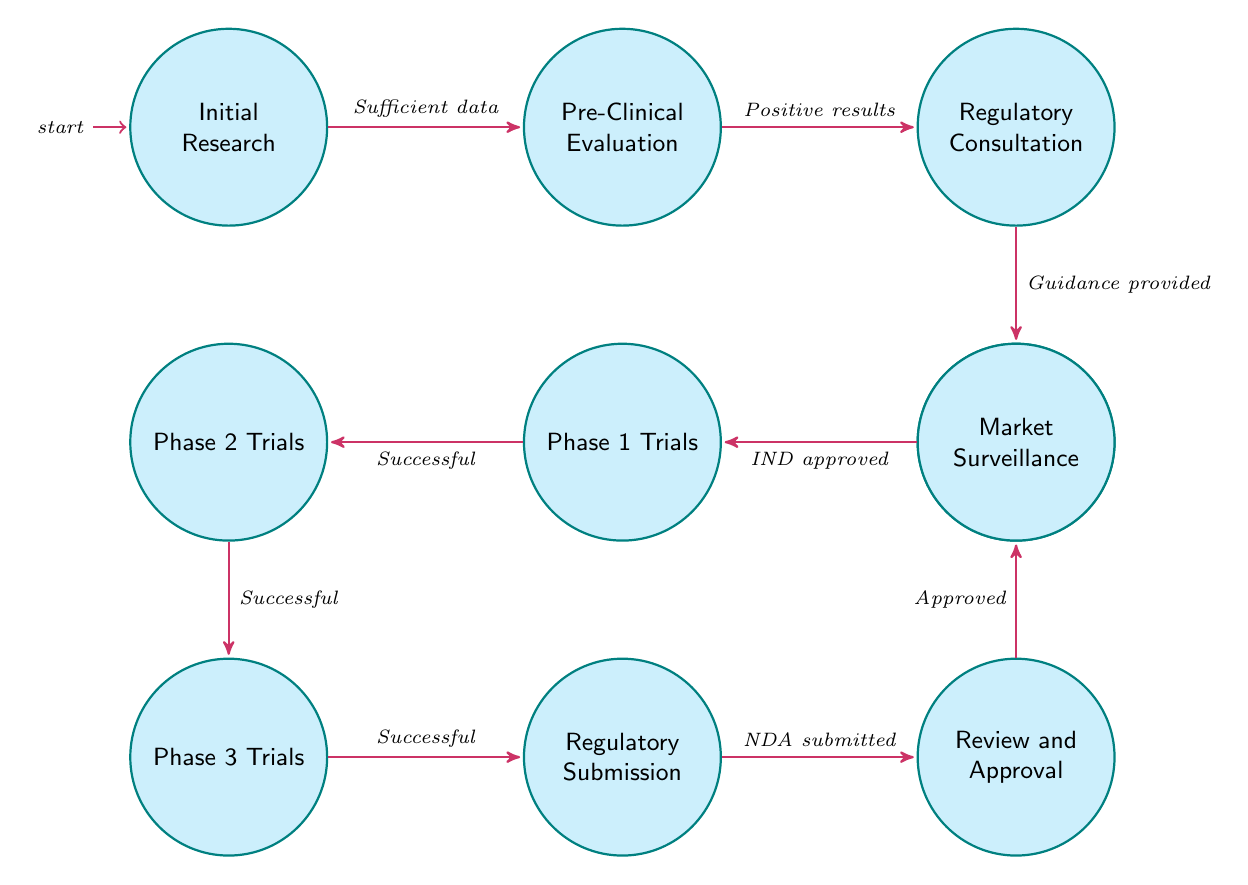What is the first state in the diagram? The diagram starts with the node labeled "Initial Research," which is the starting point of the entire process.
Answer: Initial Research How many total states are present in the diagram? By counting the individual states visually represented in the diagram, we find there are ten distinct states that outline the process for introducing new natural remedies.
Answer: 10 What follows after "Pre-Clinical Evaluation"? In the flow of the diagram, the transition from "Pre-Clinical Evaluation" leads to "Regulatory Consultation," indicating that this is the next step to take after completing the pre-clinical evaluation.
Answer: Regulatory Consultation What condition must be met to move from "Phase 2 Trials" to "Phase 3 Trials"? According to the diagram, the transition from "Phase 2 Trials" to "Phase 3 Trials" occurs when the Phase 2 trials are deemed successful, allowing for progression to the next phase.
Answer: Successful Which state is reached after submitting the NDA? Following the submission of the New Drug Application (NDA), the process progresses to the "Review and Approval" state, where the regulatory body assesses the submitted information.
Answer: Review and Approval What is the final step after receiving regulatory approval? The last step in the diagram indicates that after obtaining regulatory approval, the process concludes with "Market Surveillance," which involves monitoring the remedy in the market for its performance and safety.
Answer: Market Surveillance What must occur before conducting Phase 1 Trials? The diagram specifies that to proceed to "Phase 1 Trials," the "Clinical Trial Application" must be approved, as indicated by the lead arrow connecting these two states.
Answer: IND approved What condition allows for regulatory consultation? The diagram describes that regulatory consultation can only take place following the receipt of positive results from the pre-clinical evaluation phase, which is a prerequisite for this action.
Answer: Positive results How many transitions are there in the diagram? Counting the arrows that indicate movement from one state to another provides us with a total of nine transitions that represent the various steps in the process.
Answer: 9 